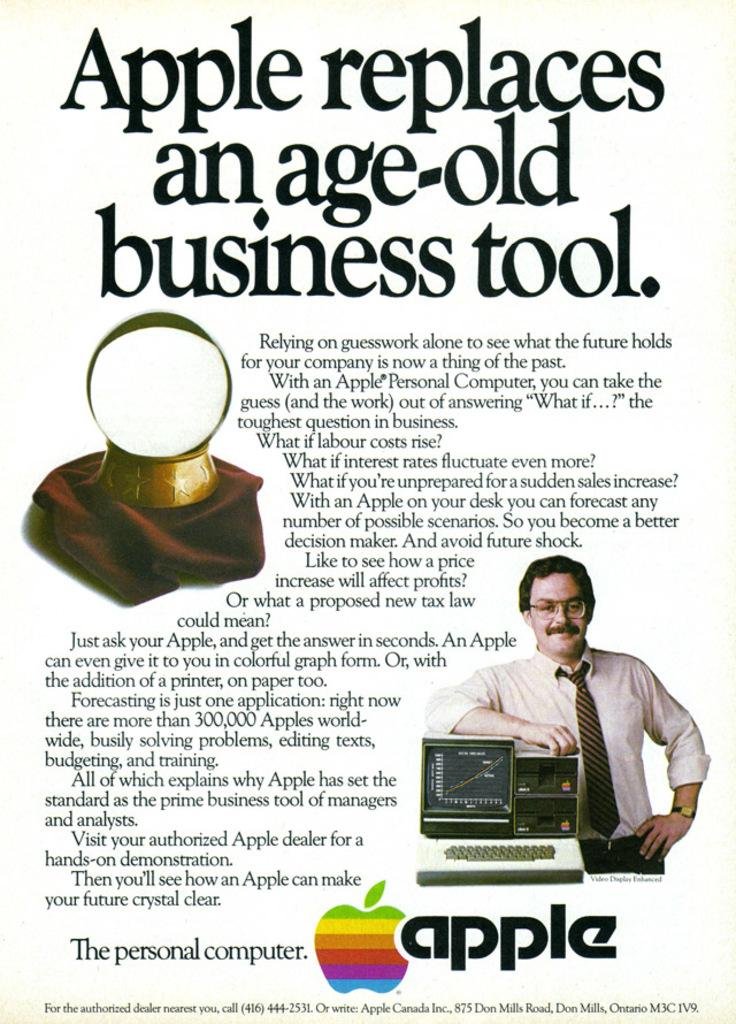<image>
Describe the image concisely. An ad for apple personal computers that proclaims at the top that Apple replaces an age-old business tool. 